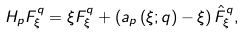<formula> <loc_0><loc_0><loc_500><loc_500>H _ { p } F _ { \xi } ^ { q } = \xi F _ { \xi } ^ { q } + \left ( a _ { p } \left ( \xi ; q \right ) - \xi \right ) \hat { F } _ { \xi } ^ { q } ,</formula> 